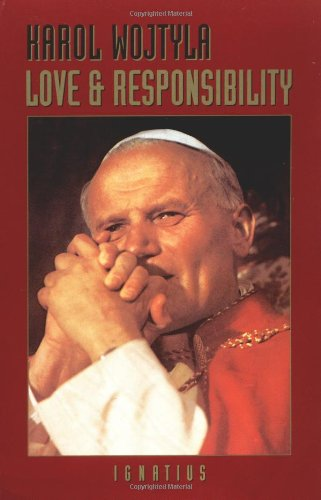Who is the author of this book? The author of the book, as shown in the image, is Karol Wojtyla, also known as Pope John Paul II. He was a significant figure not only in religious circles but also as a philosopher and writer. 